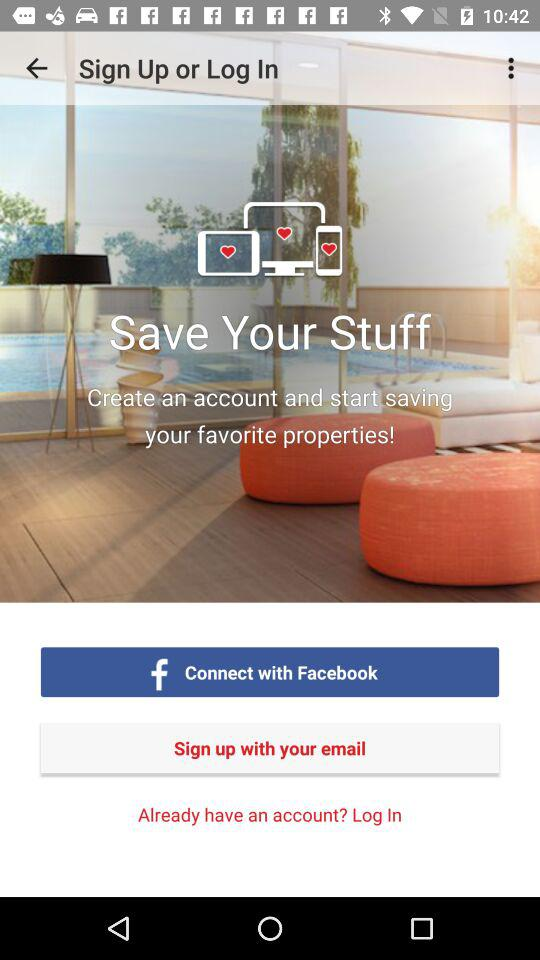What application can be used for connecting? The application that can be used for connecting is "Facebook". 